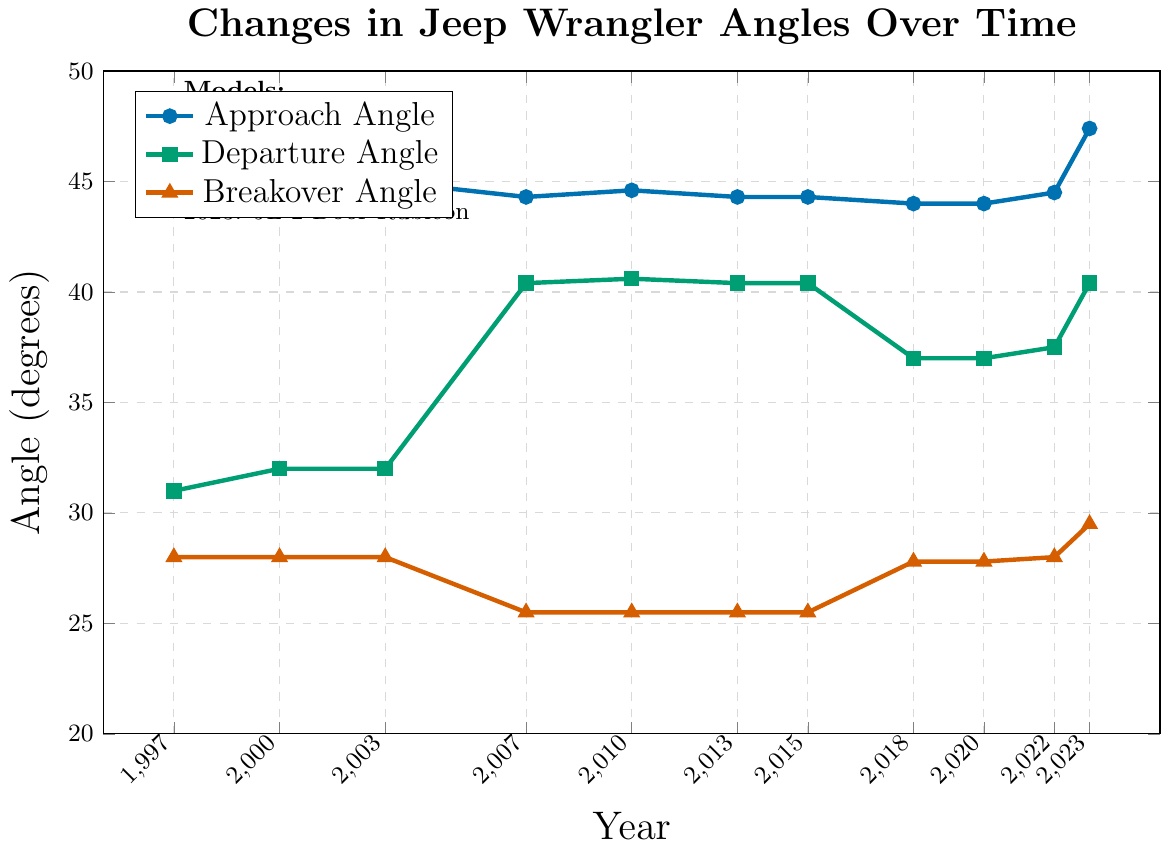What year had the highest approach angle in the plot? The highest approach angle in the plot is represented by the tallest point on the blue line. The year corresponding to this point is 2023.
Answer: 2023 How did the breakover angle change between the JK 2-Door and JL 2-Door models? The breakover angle for the JK 2-Door model started at 25.5 degrees and ended there. For the JL 2-Door model, it increased from 27.8 degrees to 29.5 degrees.
Answer: Increased Which year had the biggest increase in departure angle compared to its previous measurement? By examining the green line, the biggest jump in departure angle occurred from 2003 to 2007, showing an increase from 32 degrees to 40.4 degrees.
Answer: 2007 What is the average approach angle for the TJ model across all years? The approach angles for the TJ model in the years 1997, 2000, and 2003 are 44, 44, and 45 degrees respectively. Their average is calculated as (44 + 44 + 45) / 3 = 44.33 degrees.
Answer: 44.33 Between the years 2018 and 2020, which angle remained constant, and which ones changed? From 2018 to 2020, the approach angle and breakover angle remained constant (44 degrees and 27.8 degrees), while the departure angle remained at 37 degrees.
Answer: Breakover and Approach Is there any year where all three angles are exactly the same as in another year? No, each year has at least one angle that differs from any other year.
Answer: No In which year does the JL model first appear on the graph, and what are the corresponding angles? The JL model first appears in 2018 with an approach angle of 44 degrees, a departure angle of 37 degrees, and a breakover angle of 27.8 degrees.
Answer: 2018, 44, 37, 27.8 Compare the angular change in departure angle from 2003 to 2007 and from 2022 to 2023. From 2003 to 2007, the departure angle increased from 32 to 40.4 degrees, a change of +8.4 degrees. From 2022 to 2023, it increased from 37.5 to 40.4 degrees, a change of +2.9 degrees.
Answer: +8.4, +2.9 